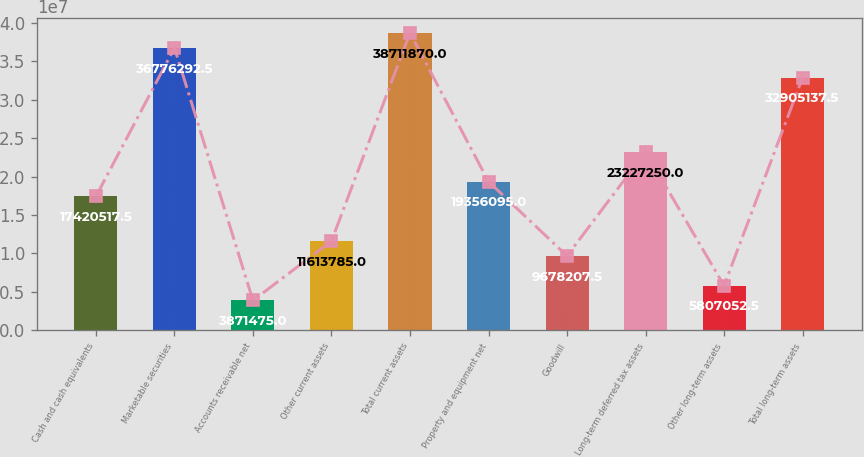Convert chart to OTSL. <chart><loc_0><loc_0><loc_500><loc_500><bar_chart><fcel>Cash and cash equivalents<fcel>Marketable securities<fcel>Accounts receivable net<fcel>Other current assets<fcel>Total current assets<fcel>Property and equipment net<fcel>Goodwill<fcel>Long-term deferred tax assets<fcel>Other long-term assets<fcel>Total long-term assets<nl><fcel>1.74205e+07<fcel>3.67763e+07<fcel>3.87148e+06<fcel>1.16138e+07<fcel>3.87119e+07<fcel>1.93561e+07<fcel>9.67821e+06<fcel>2.32272e+07<fcel>5.80705e+06<fcel>3.29051e+07<nl></chart> 